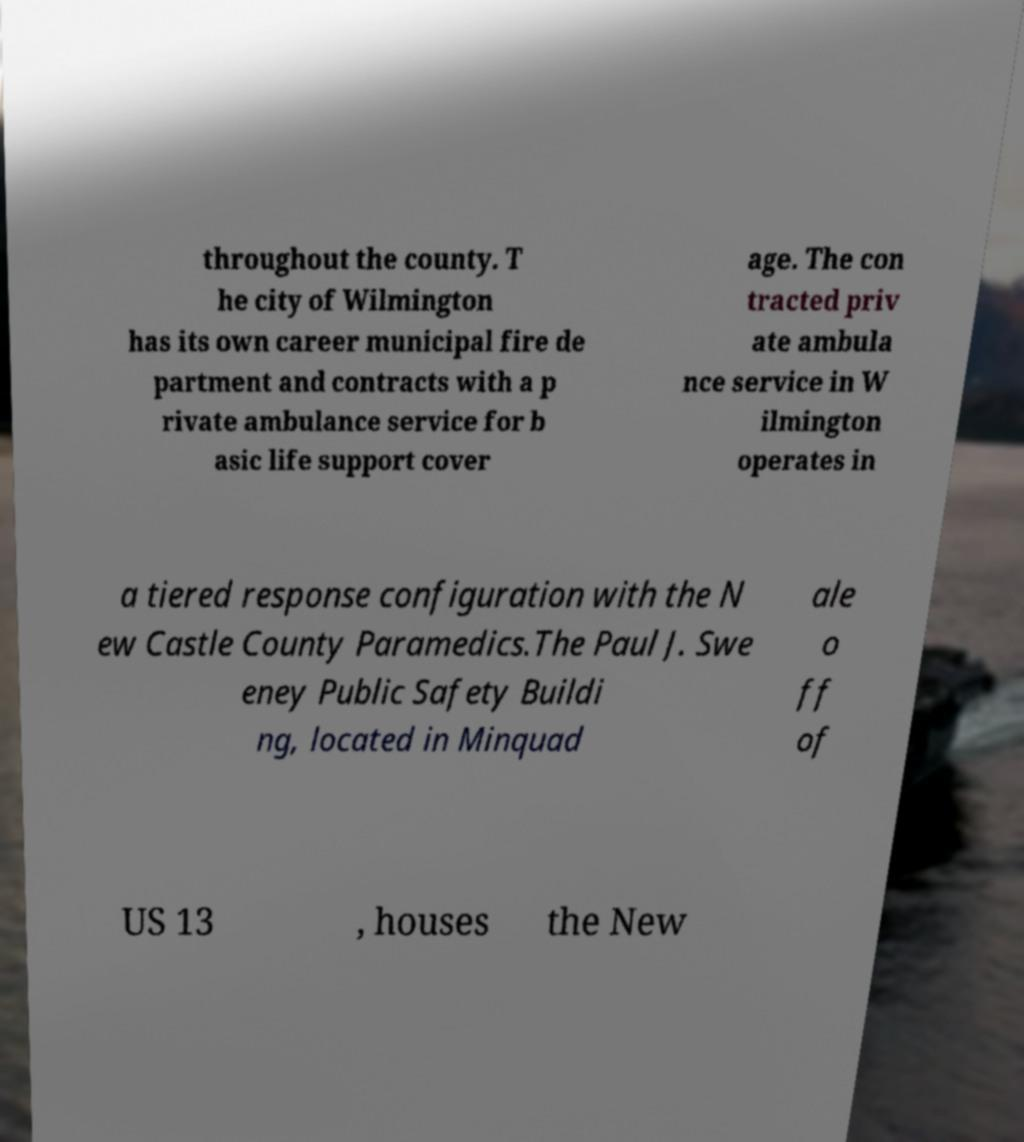Can you read and provide the text displayed in the image?This photo seems to have some interesting text. Can you extract and type it out for me? throughout the county. T he city of Wilmington has its own career municipal fire de partment and contracts with a p rivate ambulance service for b asic life support cover age. The con tracted priv ate ambula nce service in W ilmington operates in a tiered response configuration with the N ew Castle County Paramedics.The Paul J. Swe eney Public Safety Buildi ng, located in Minquad ale o ff of US 13 , houses the New 